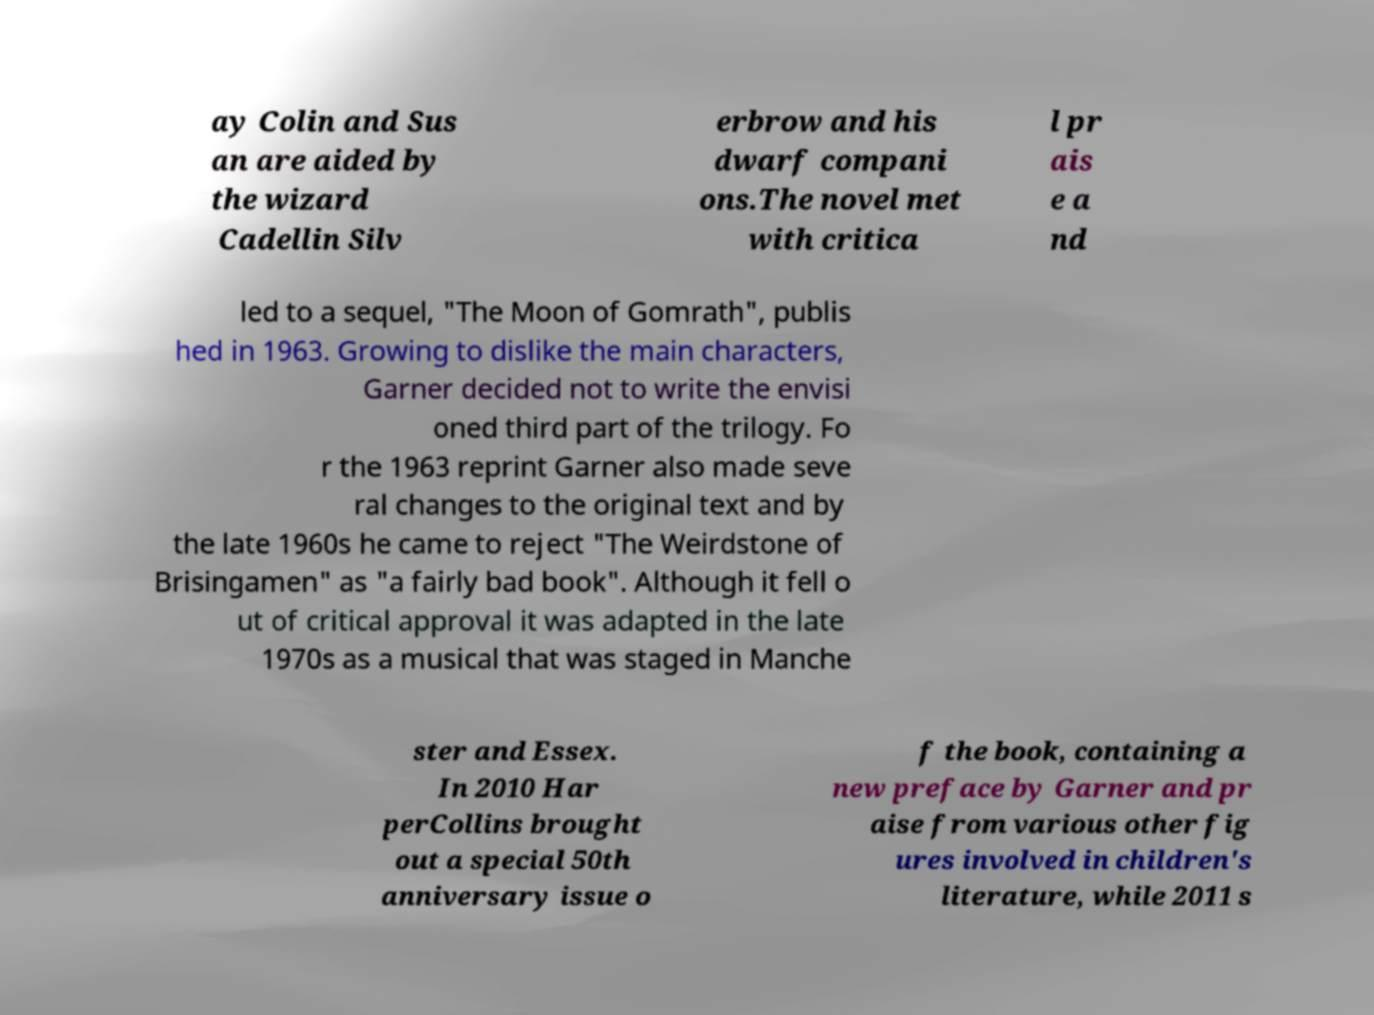For documentation purposes, I need the text within this image transcribed. Could you provide that? ay Colin and Sus an are aided by the wizard Cadellin Silv erbrow and his dwarf compani ons.The novel met with critica l pr ais e a nd led to a sequel, "The Moon of Gomrath", publis hed in 1963. Growing to dislike the main characters, Garner decided not to write the envisi oned third part of the trilogy. Fo r the 1963 reprint Garner also made seve ral changes to the original text and by the late 1960s he came to reject "The Weirdstone of Brisingamen" as "a fairly bad book". Although it fell o ut of critical approval it was adapted in the late 1970s as a musical that was staged in Manche ster and Essex. In 2010 Har perCollins brought out a special 50th anniversary issue o f the book, containing a new preface by Garner and pr aise from various other fig ures involved in children's literature, while 2011 s 